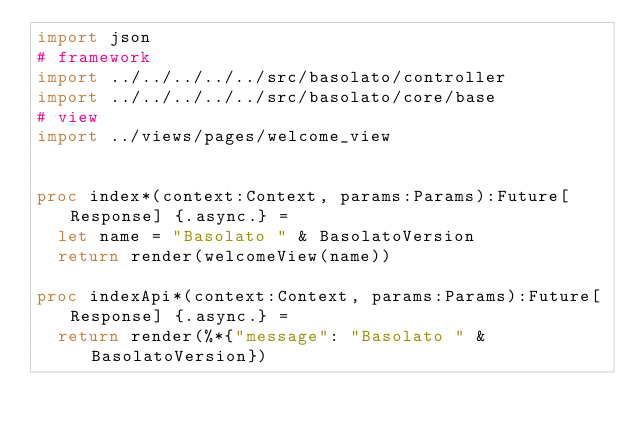Convert code to text. <code><loc_0><loc_0><loc_500><loc_500><_Nim_>import json
# framework
import ../../../../../src/basolato/controller
import ../../../../../src/basolato/core/base
# view
import ../views/pages/welcome_view


proc index*(context:Context, params:Params):Future[Response] {.async.} =
  let name = "Basolato " & BasolatoVersion
  return render(welcomeView(name))

proc indexApi*(context:Context, params:Params):Future[Response] {.async.} =
  return render(%*{"message": "Basolato " & BasolatoVersion})
</code> 